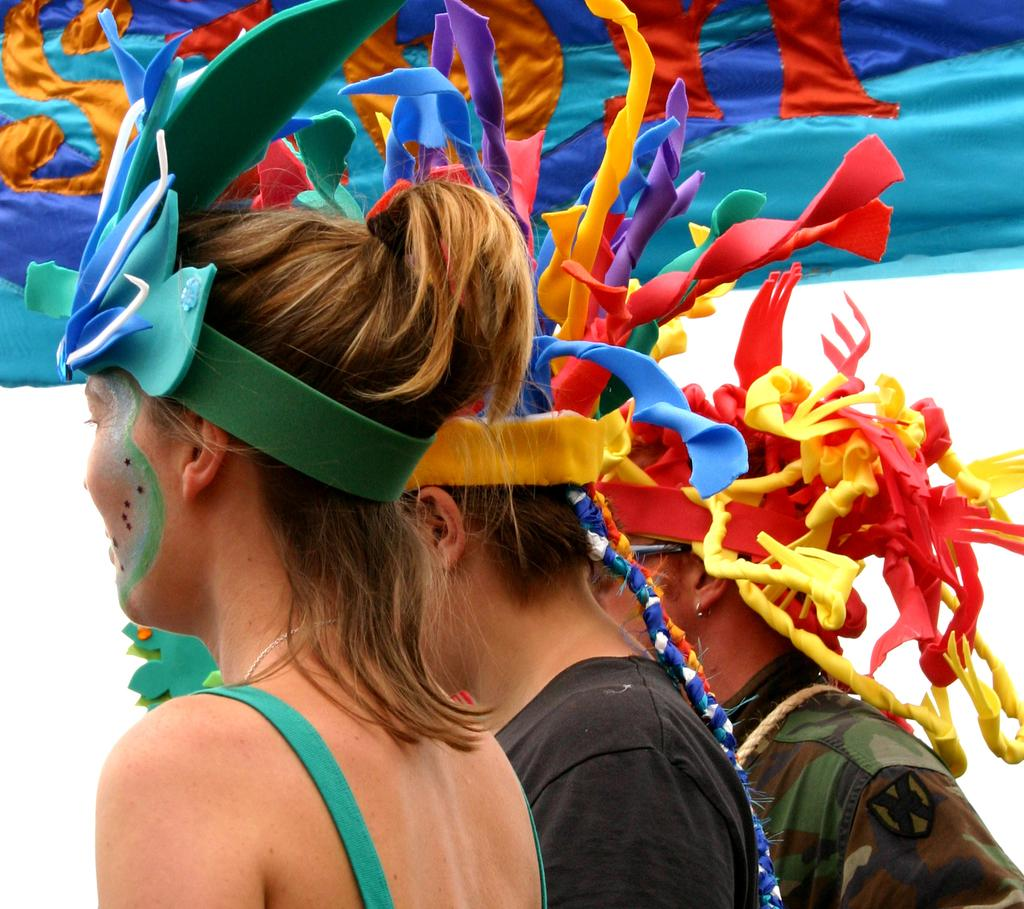How many people are in the image? There are three persons in the image. What are the persons doing in the image? The persons are standing. What are the persons wearing in the image? The persons are wearing costumes. What can be seen in the background of the image? There is a cloth visible in the background of the image. What type of cream can be seen on the chairs in the image? There are no chairs or cream present in the image. What color is the thread used in the costumes of the persons in the image? The provided facts do not mention the color or type of thread used in the costumes. 